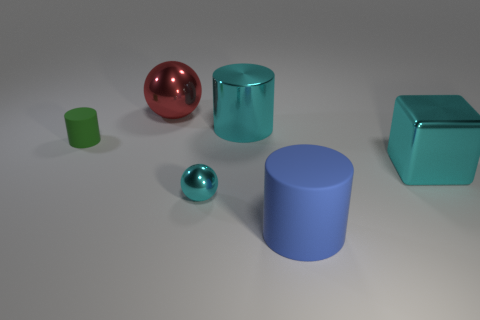Subtract all cyan shiny cylinders. How many cylinders are left? 2 Add 4 large red shiny objects. How many objects exist? 10 Subtract all cyan balls. How many balls are left? 1 Subtract all cubes. How many objects are left? 5 Subtract all yellow objects. Subtract all small cyan things. How many objects are left? 5 Add 1 small green rubber cylinders. How many small green rubber cylinders are left? 2 Add 1 tiny matte cylinders. How many tiny matte cylinders exist? 2 Subtract 0 yellow cubes. How many objects are left? 6 Subtract 1 cylinders. How many cylinders are left? 2 Subtract all green cubes. Subtract all gray cylinders. How many cubes are left? 1 